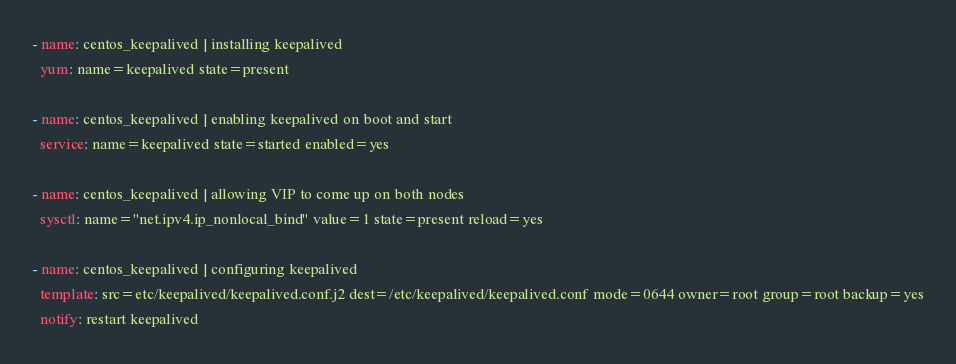Convert code to text. <code><loc_0><loc_0><loc_500><loc_500><_YAML_>- name: centos_keepalived | installing keepalived
  yum: name=keepalived state=present

- name: centos_keepalived | enabling keepalived on boot and start
  service: name=keepalived state=started enabled=yes

- name: centos_keepalived | allowing VIP to come up on both nodes
  sysctl: name="net.ipv4.ip_nonlocal_bind" value=1 state=present reload=yes

- name: centos_keepalived | configuring keepalived
  template: src=etc/keepalived/keepalived.conf.j2 dest=/etc/keepalived/keepalived.conf mode=0644 owner=root group=root backup=yes
  notify: restart keepalived
</code> 